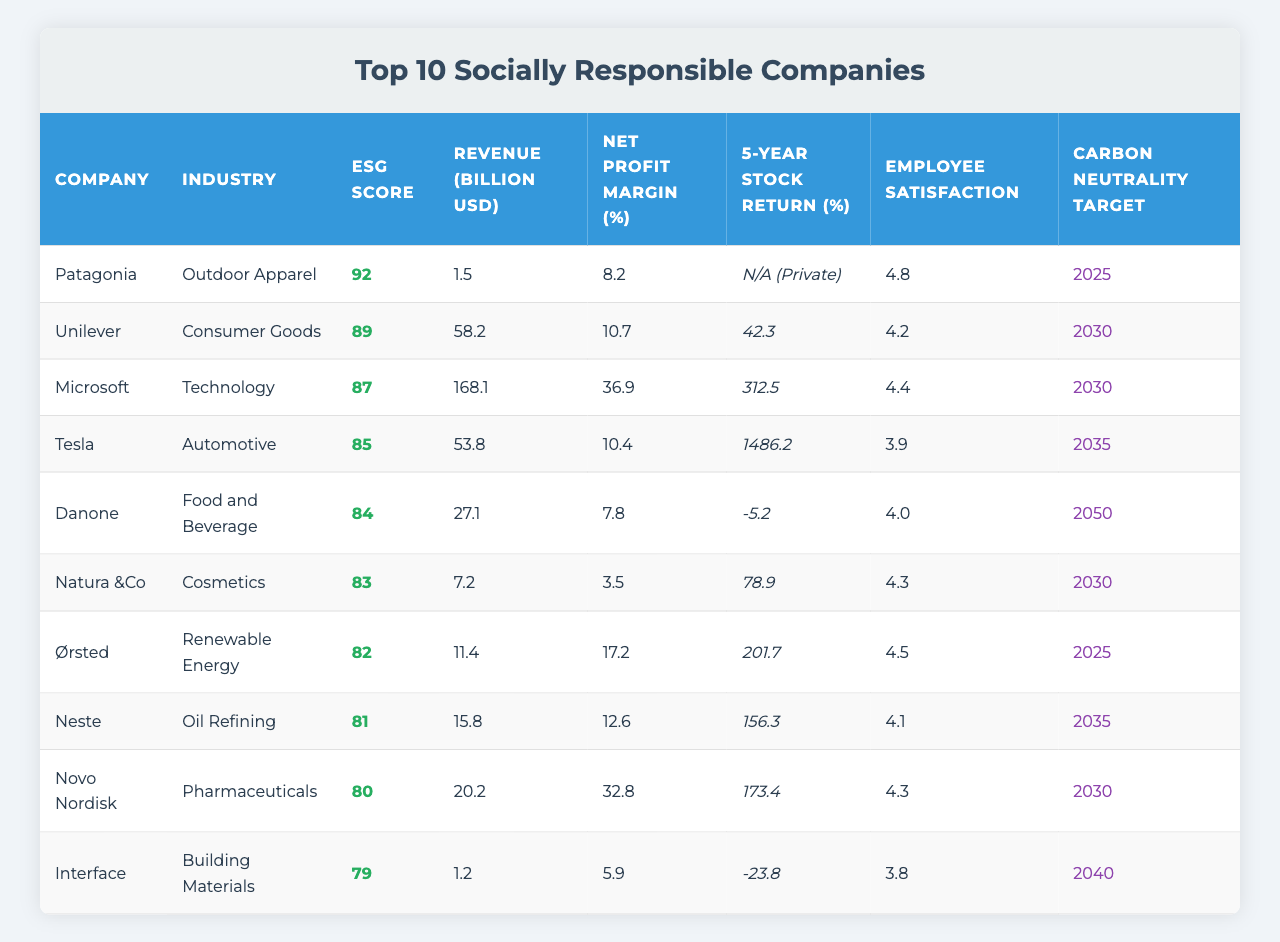What's the company with the highest ESG score? By examining the "ESG Score" column, we see that Patagonia has the highest score of 92.
Answer: Patagonia What industry does Microsoft belong to? Looking at the "Industry" column next to Microsoft, we identify that it is in the Technology sector.
Answer: Technology Which company has the lowest revenue? In the "Revenue (Billion USD)" column, the lowest value is 1.2, which corresponds to Interface.
Answer: Interface What is the employee satisfaction rating for Unilever? Checking the "Employee Satisfaction" column for Unilever, it shows a rating of 4.2.
Answer: 4.2 Is Tesla's net profit margin greater than 10%? The net profit margin for Tesla is 10.4%, which is indeed greater than 10%.
Answer: Yes What is the average ESG score of the top five companies listed? The ESG scores for the top five companies are 92, 89, 87, 85, and 84. Adding these gives 437, and dividing by 5 yields an average score of 87.4.
Answer: 87.4 Which company has the highest 5-year stock return? The "5-Year Stock Return (%)" column shows Tesla with an astonishing return of 1486.2%, which is the highest among all companies.
Answer: Tesla How many companies have a carbon neutrality target set for 2030? Examining the "Carbon Neutrality Target" column, we count Unilever, Microsoft, Natura &Co, and Novo Nordisk, making a total of 4 companies.
Answer: 4 What is the difference in net profit margin between Novo Nordisk and Danone? The net profit margin for Novo Nordisk is 32.8%, while for Danone, it is 7.8%. The difference is 32.8 - 7.8 = 25%.
Answer: 25% Which company has the best employee satisfaction rating, and what is that rating? Looking through the "Employee Satisfaction" column, Patagonia has the highest rating of 4.8.
Answer: Patagonia, 4.8 